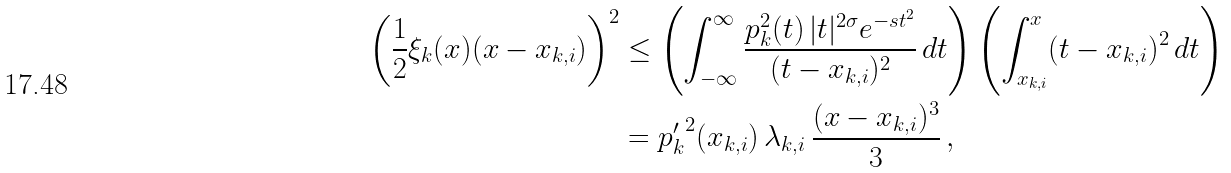<formula> <loc_0><loc_0><loc_500><loc_500>\left ( \frac { 1 } { 2 } \xi _ { k } ( x ) ( x - x _ { k , i } ) \right ) ^ { 2 } & \leq \left ( \int _ { - \infty } ^ { \infty } \frac { p _ { k } ^ { 2 } ( t ) \, | t | ^ { 2 \sigma } e ^ { - s t ^ { 2 } } } { ( t - x _ { k , i } ) ^ { 2 } } \, d t \right ) \left ( \int _ { x _ { k , i } } ^ { x } ( t - x _ { k , i } ) ^ { 2 } \, d t \right ) \\ & = { p _ { k } ^ { \prime } } ^ { 2 } ( x _ { k , i } ) \, \lambda _ { k , i } \, \frac { ( x - x _ { k , i } ) ^ { 3 } } { 3 } \, ,</formula> 